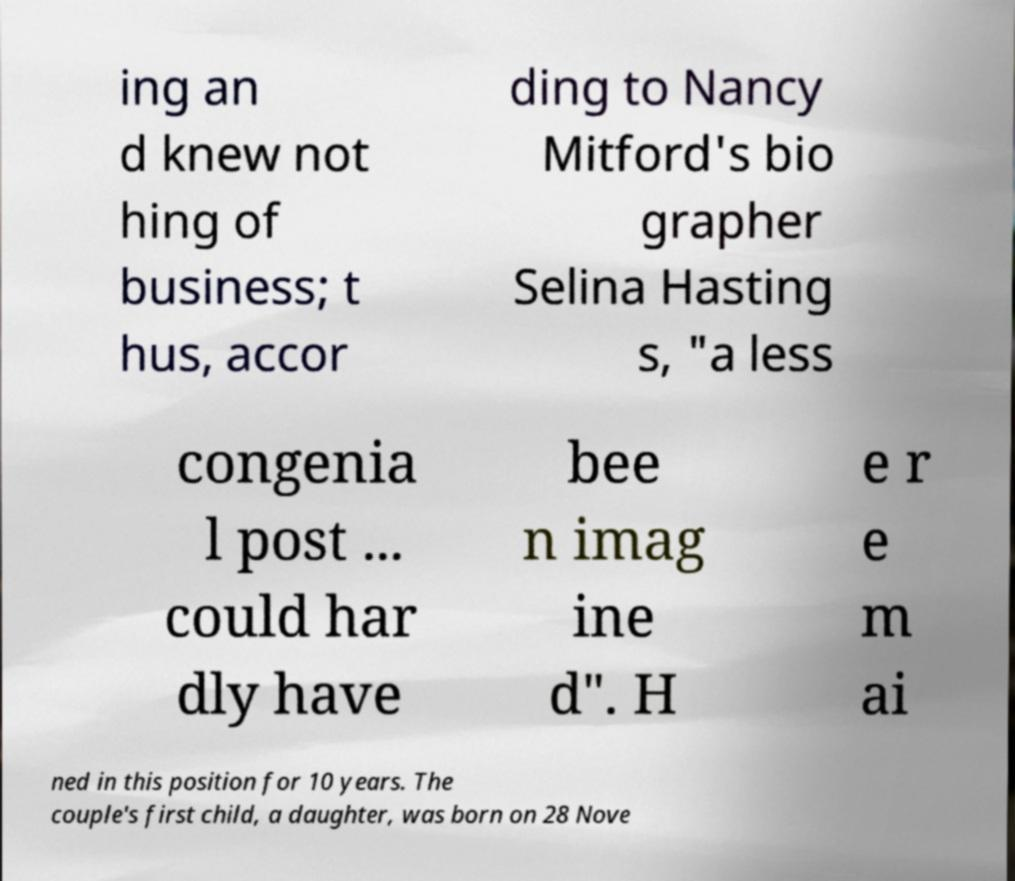Could you extract and type out the text from this image? ing an d knew not hing of business; t hus, accor ding to Nancy Mitford's bio grapher Selina Hasting s, "a less congenia l post ... could har dly have bee n imag ine d". H e r e m ai ned in this position for 10 years. The couple's first child, a daughter, was born on 28 Nove 